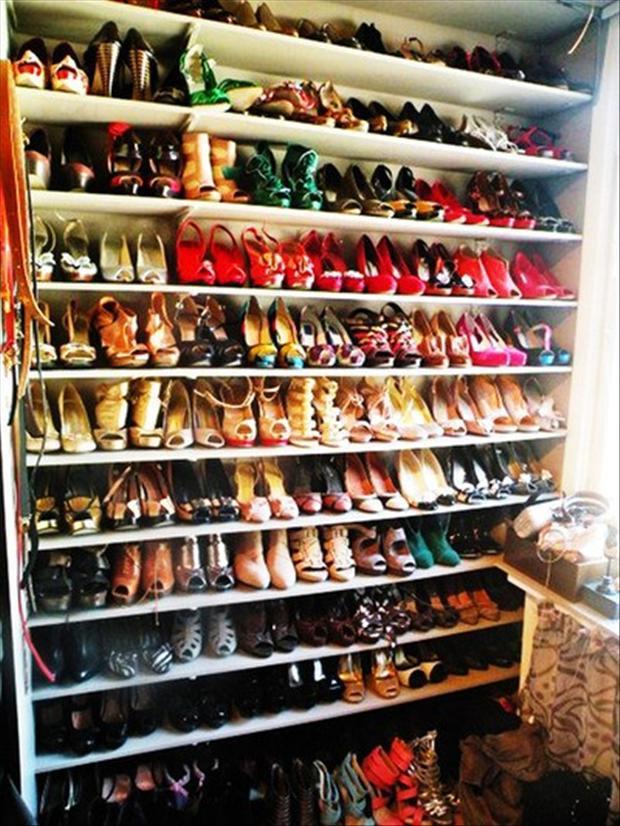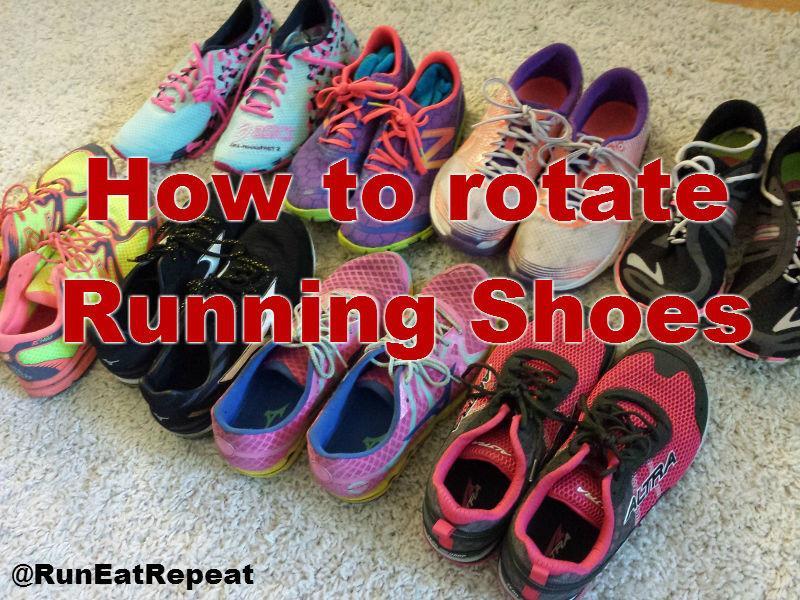The first image is the image on the left, the second image is the image on the right. Examine the images to the left and right. Is the description "One image shows several pairs of shoes lined up neatly on the floor." accurate? Answer yes or no. Yes. The first image is the image on the left, the second image is the image on the right. Analyze the images presented: Is the assertion "The left image shows many shoes arranged in rows on shelves." valid? Answer yes or no. Yes. 